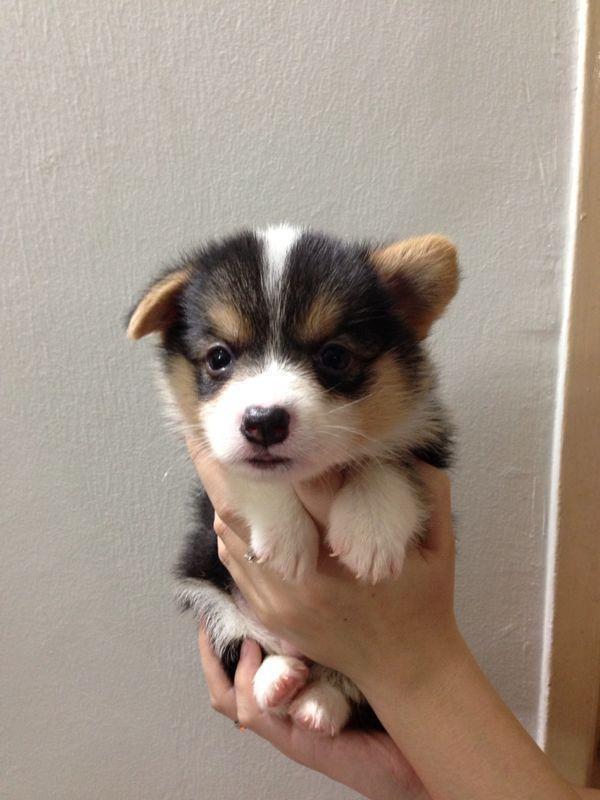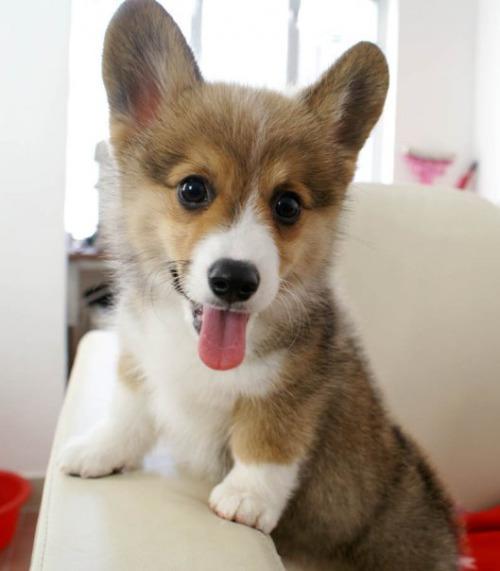The first image is the image on the left, the second image is the image on the right. For the images shown, is this caption "A small dog with its tongue hanging out is on a light colored chair." true? Answer yes or no. Yes. The first image is the image on the left, the second image is the image on the right. For the images displayed, is the sentence "One puppy has their tongue out." factually correct? Answer yes or no. Yes. 